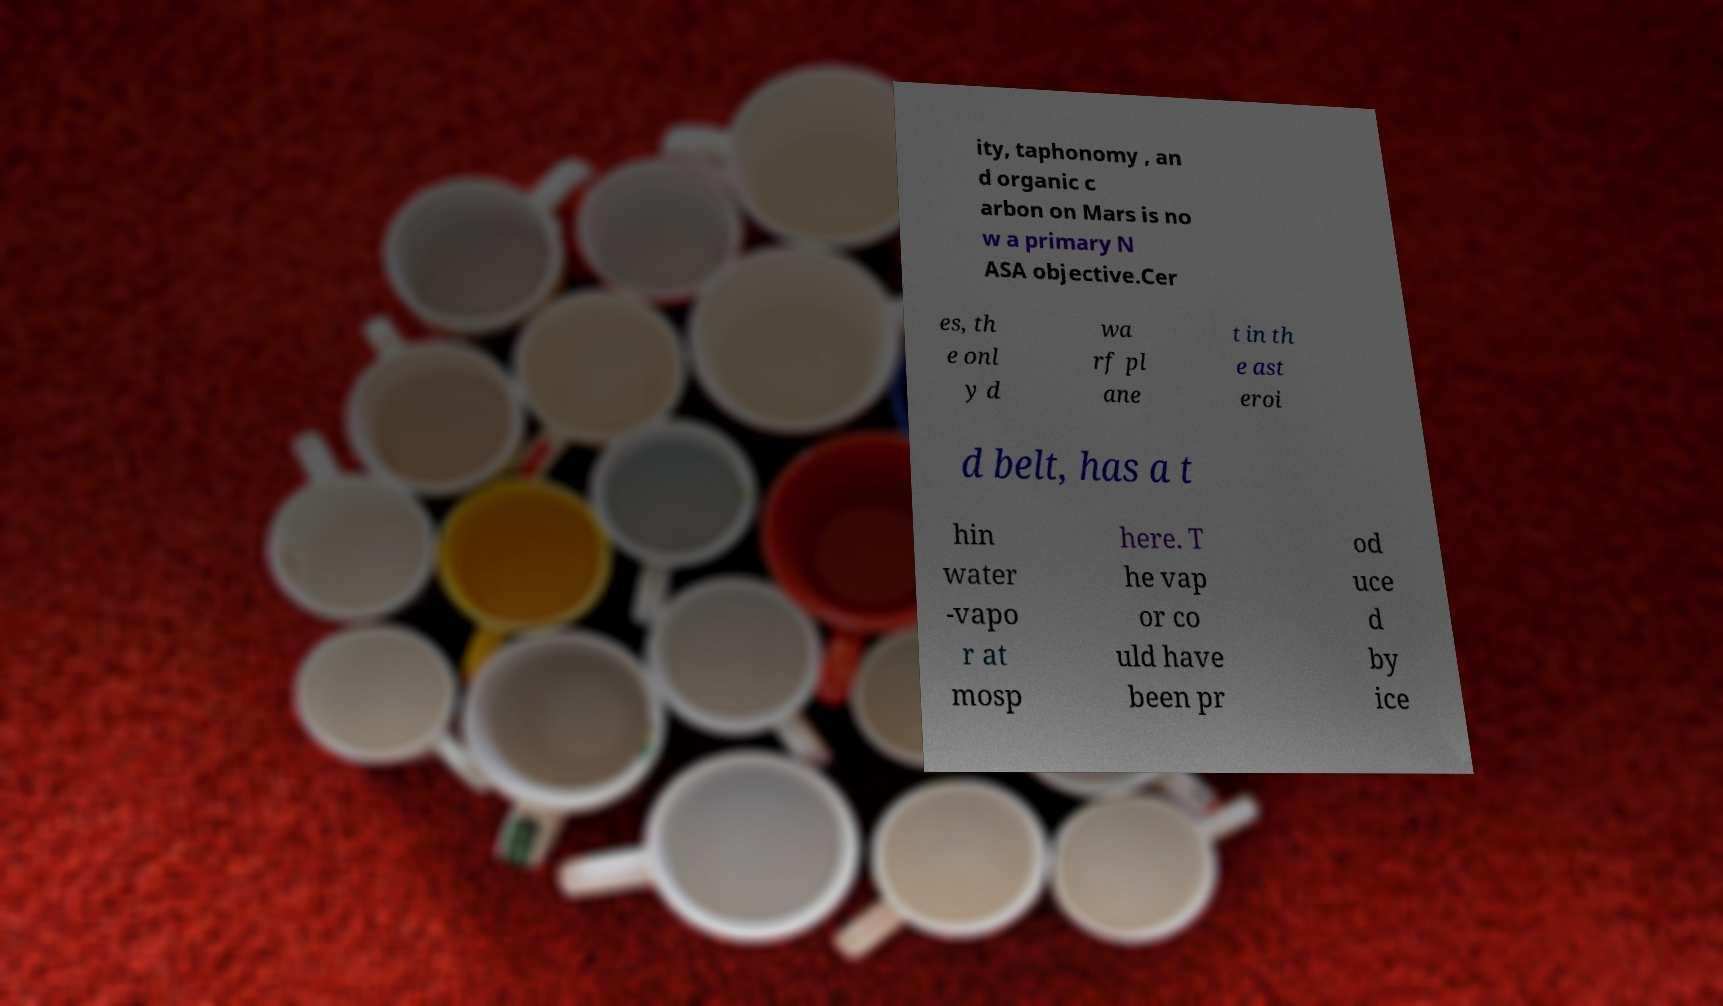Please read and relay the text visible in this image. What does it say? ity, taphonomy , an d organic c arbon on Mars is no w a primary N ASA objective.Cer es, th e onl y d wa rf pl ane t in th e ast eroi d belt, has a t hin water -vapo r at mosp here. T he vap or co uld have been pr od uce d by ice 